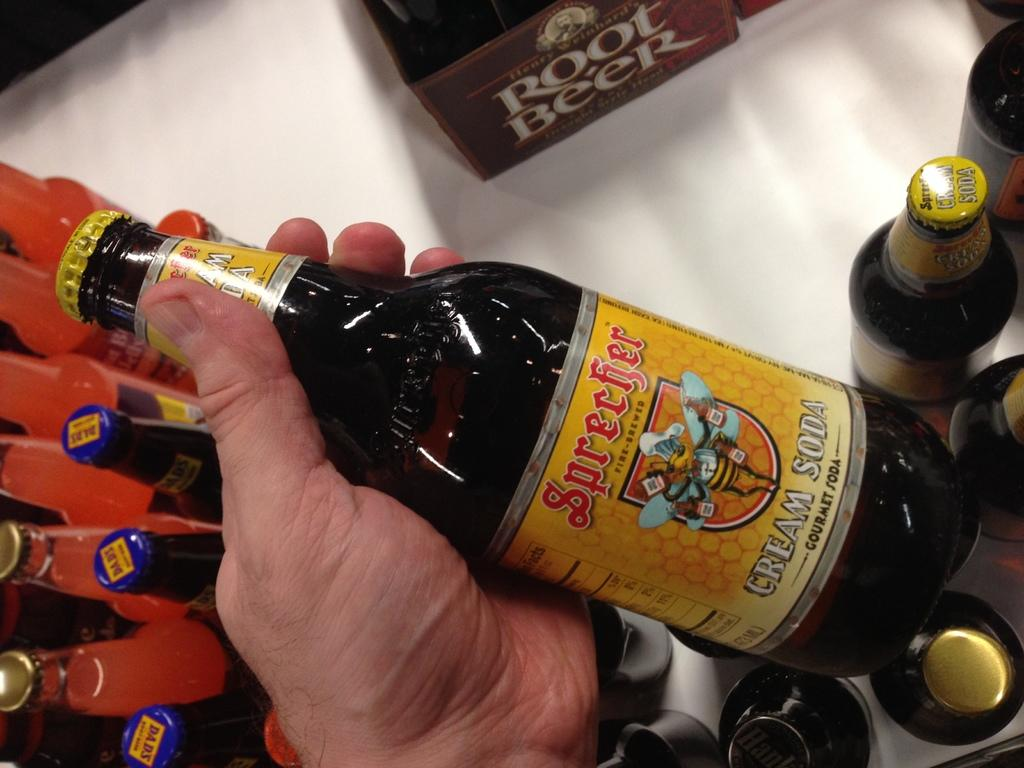Provide a one-sentence caption for the provided image. bottle of cream soda by the brand sprecfer root beer. 